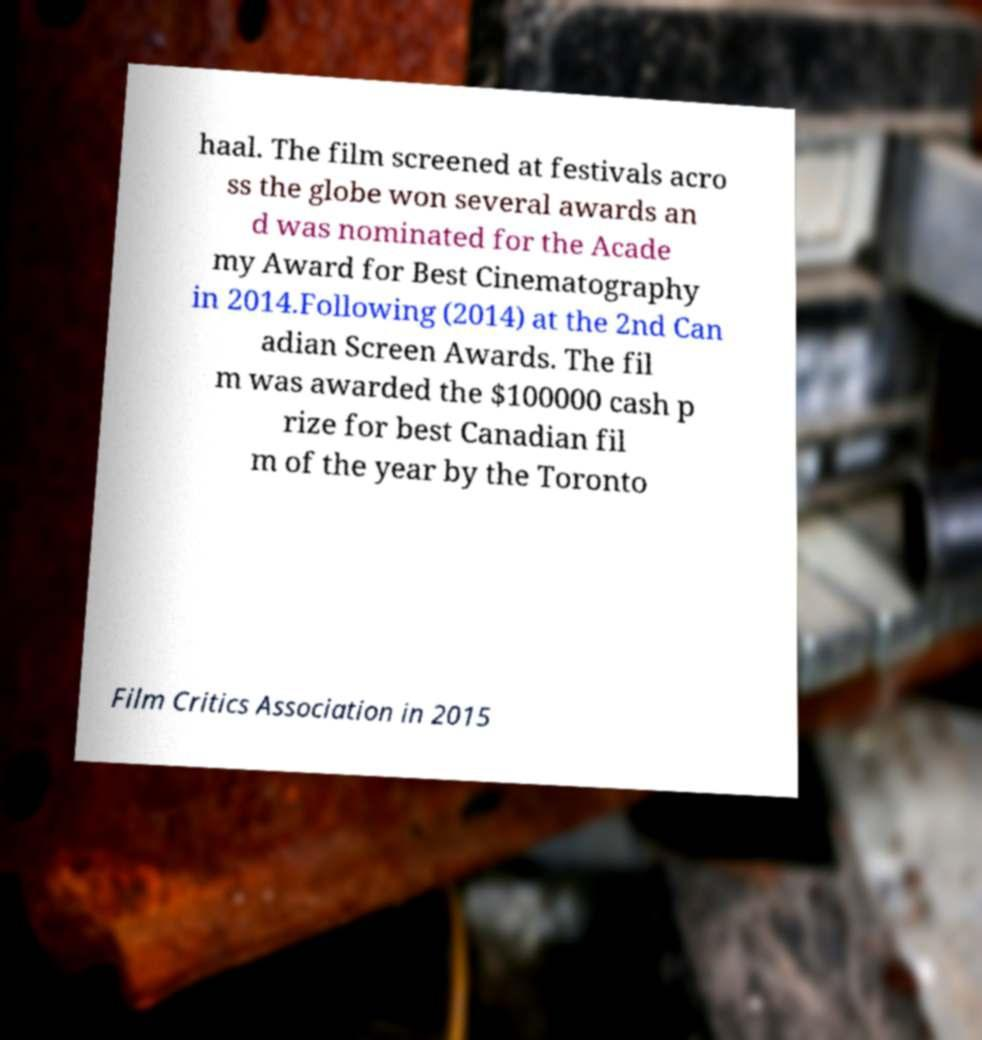What messages or text are displayed in this image? I need them in a readable, typed format. haal. The film screened at festivals acro ss the globe won several awards an d was nominated for the Acade my Award for Best Cinematography in 2014.Following (2014) at the 2nd Can adian Screen Awards. The fil m was awarded the $100000 cash p rize for best Canadian fil m of the year by the Toronto Film Critics Association in 2015 